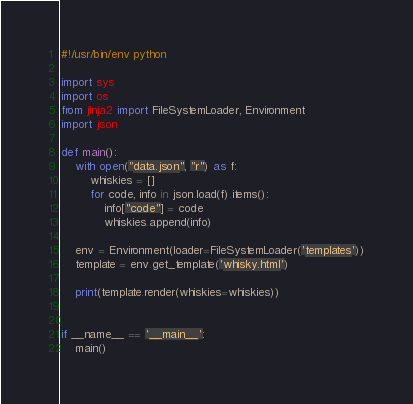<code> <loc_0><loc_0><loc_500><loc_500><_Python_>#!/usr/bin/env python

import sys
import os
from jinja2 import FileSystemLoader, Environment
import json

def main():
    with open("data.json", "r") as f:
        whiskies = []
        for code, info in json.load(f).items():
            info["code"] = code
            whiskies.append(info)

    env = Environment(loader=FileSystemLoader('templates'))
    template = env.get_template('whisky.html')

    print(template.render(whiskies=whiskies))


if __name__ == '__main__':
    main()

</code> 